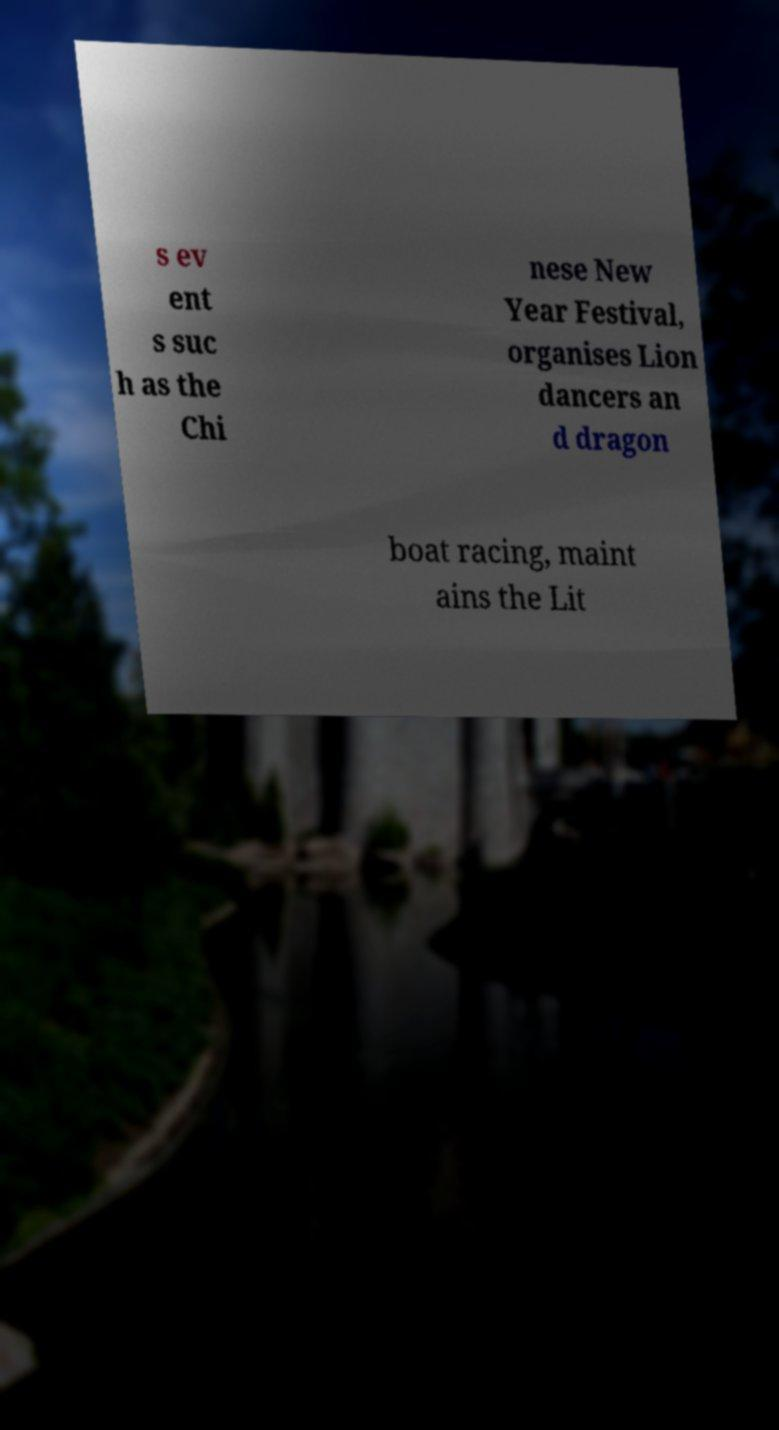Could you assist in decoding the text presented in this image and type it out clearly? s ev ent s suc h as the Chi nese New Year Festival, organises Lion dancers an d dragon boat racing, maint ains the Lit 